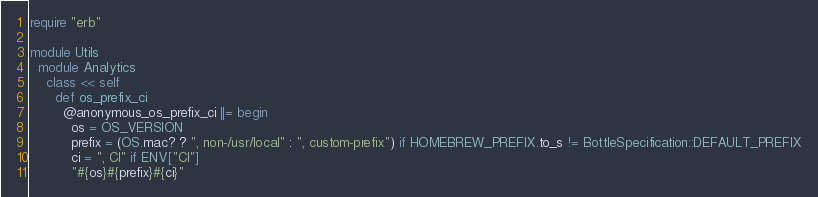Convert code to text. <code><loc_0><loc_0><loc_500><loc_500><_Ruby_>require "erb"

module Utils
  module Analytics
    class << self
      def os_prefix_ci
        @anonymous_os_prefix_ci ||= begin
          os = OS_VERSION
          prefix = (OS.mac? ? ", non-/usr/local" : ", custom-prefix") if HOMEBREW_PREFIX.to_s != BottleSpecification::DEFAULT_PREFIX
          ci = ", CI" if ENV["CI"]
          "#{os}#{prefix}#{ci}"</code> 